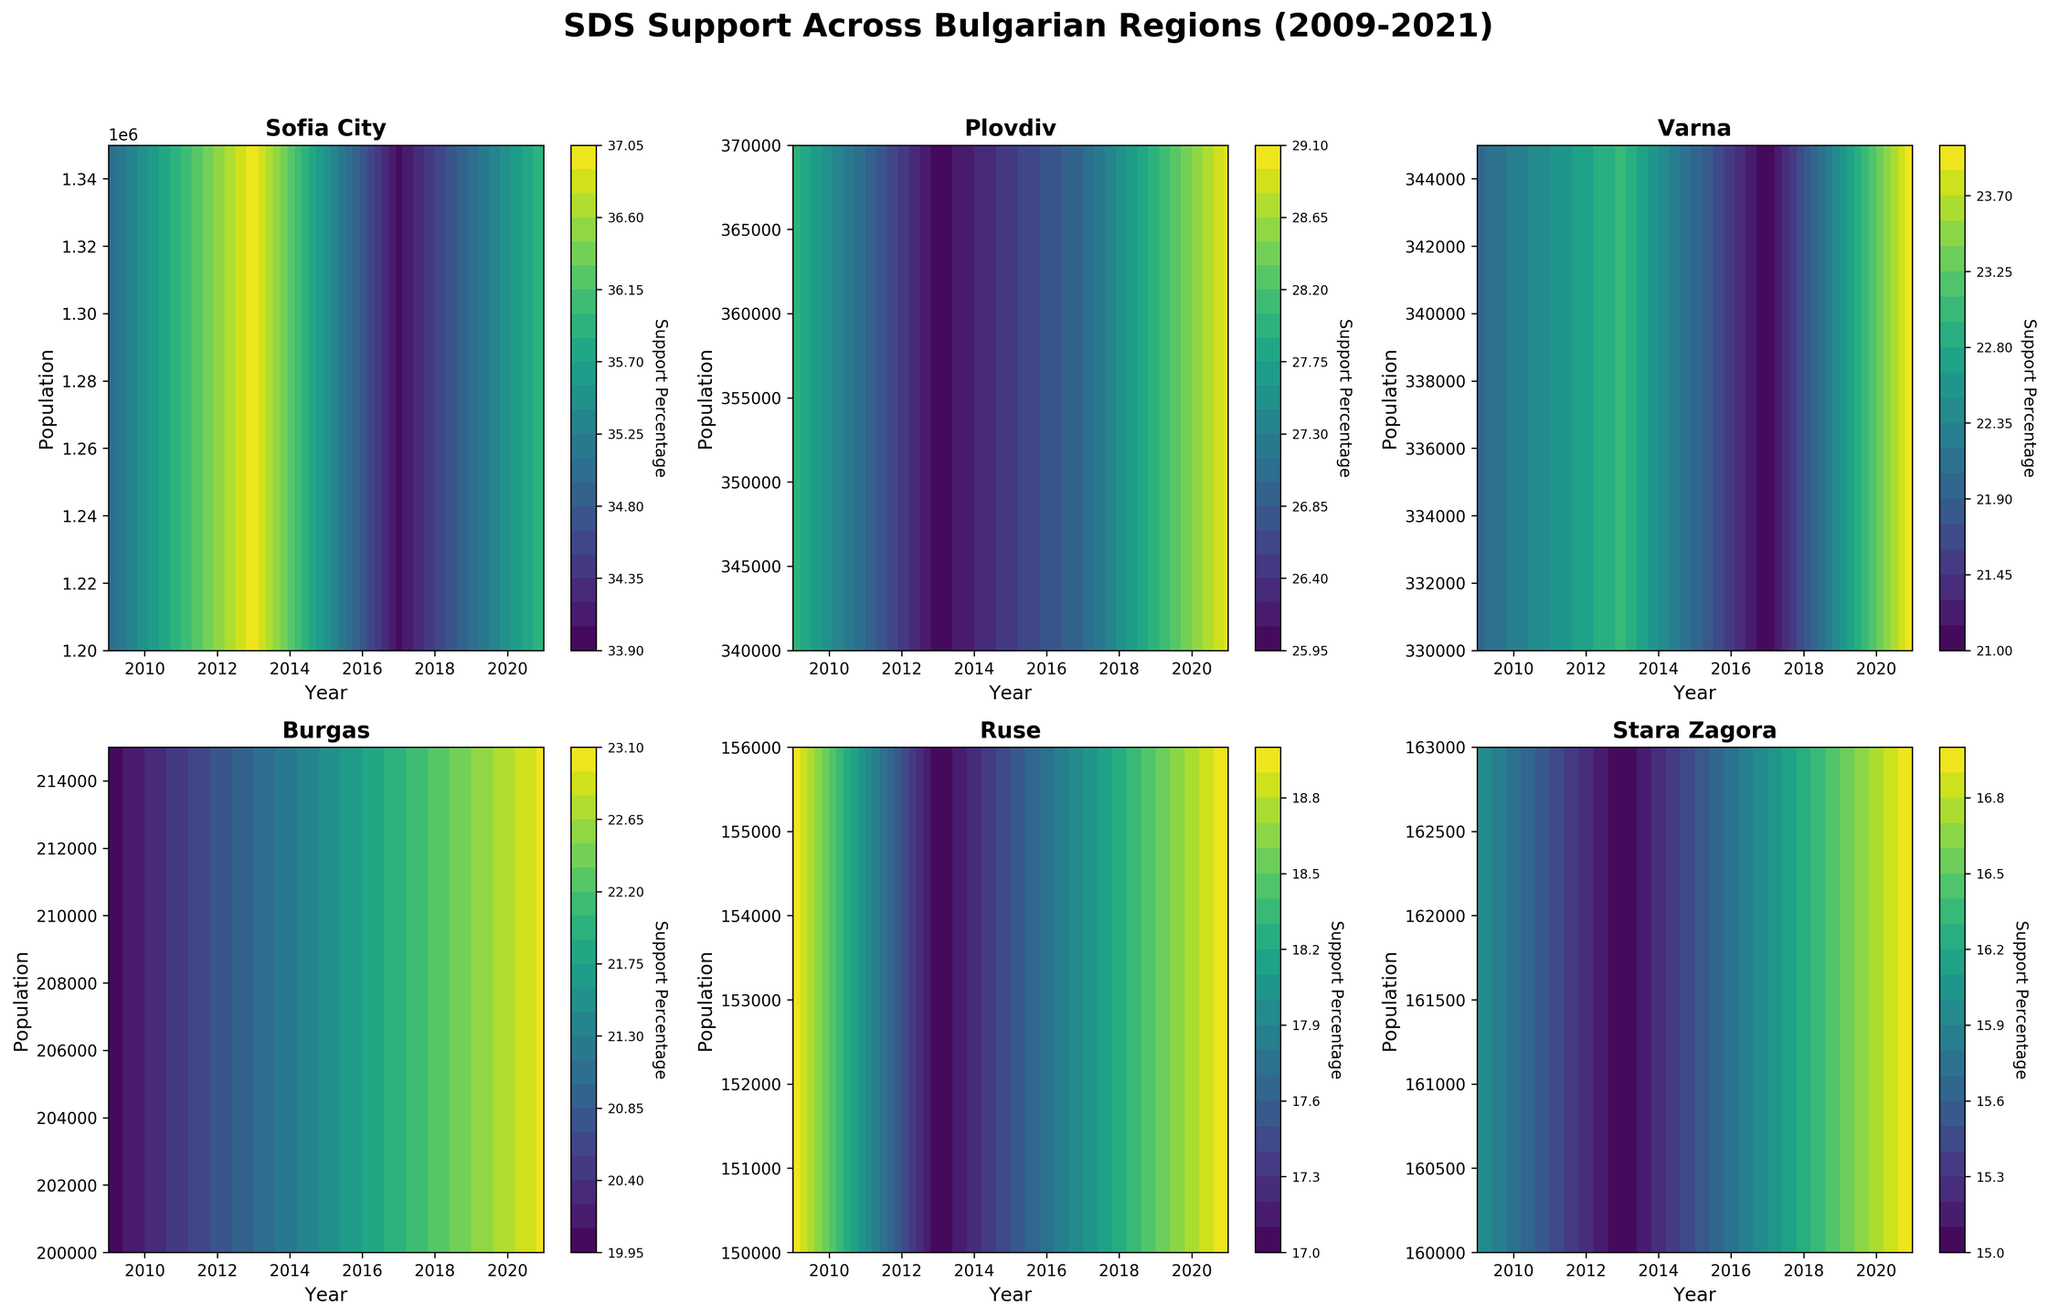What is the title of the figure? The title is displayed at the top of the figure in large, bold letters. It reads "SDS Support Across Bulgarian Regions (2009-2021)".
Answer: SDS Support Across Bulgarian Regions (2009-2021) Which region shows the highest SDS support percentage in 2021? To find the region with the highest SDS support percentage in 2021, we must look across the different regions shown and identify the highest contour level in the year 2021. "Sofia City" has the highest contour level for 2021, indicating the highest support percentage.
Answer: Sofia City In which region is the lowest SDS support percentage observed in the year 2009? Check each plot for the 2009 level (corresponding to the left-most part of the subplot for each region) and identify the lowest contour level. "Ruse" has the lowest support percentage contour level in 2009.
Answer: Ruse What trends in population do you observe in "Burgas" from 2009 to 2021? For "Burgas", look at the population values from the bottom of the subplot to the top for each year from 2009 to 2021. The population increases steadily from 200,000 in 2009 to 215,000 in 2021.
Answer: Increasing trend How does SDS support percentage in "Varna" compare between 2013 and 2017? Check the contour levels in the subplot for "Varna" at the years 2013 and 2017. The contour in 2013 is generally higher than in 2017, indicating a higher support percentage in 2013 than in 2017.
Answer: Higher in 2013 Which region depicts the most significant increase in SDS support from 2017 to 2021? Find the region where the contour for 2021 is significantly higher than the contour for 2017. "Plovdiv" and "Sofia City" both show increases, but "Sofia City" shows a more significant increase.
Answer: Sofia City Are there any regions where the SDS support percentage decreased continuously from 2009 to 2013? Check the contour levels for each region from 2009 to 2013. "Plovdiv" and "Stara Zagora" show continuous decreases in the contours for these years.
Answer: Plovdiv, Stara Zagora How does the SDS support percentage correlate with population size in "Ruse"? Analyze the contour levels within the subplot for "Ruse" to see any relationship between support percentage and population. The contour levels show a pattern where the support percentage increases slightly with population.
Answer: Slight increase What is the color scheme used in the figure, and how does it help? The color scheme used is 'viridis,' which is a gradient from purple to yellow. It helps differentiate levels of support percentage clearly, with higher support indicated by yellow and lower support by purple.
Answer: Viridis, clear differentiation In which region does the SDS support percentage remain the most consistent over the years? Identify the subplot where the contour levels change the least over the years. "Burgas" shows the most consistent support levels with minimal changes in contour lines.
Answer: Burgas 